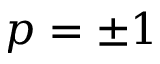<formula> <loc_0><loc_0><loc_500><loc_500>p = \pm 1</formula> 